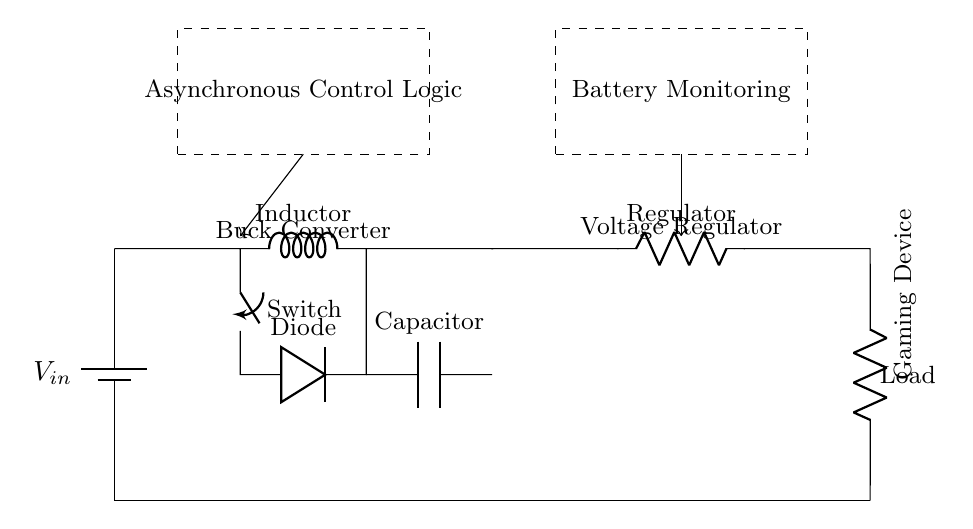What is the component used to step down voltage? The circuit includes a buck converter, which is specifically designed to reduce voltage levels efficiently. It controls the output voltage by switching and storing energy in an inductor.
Answer: Buck converter What does the dashed rectangle represent in the circuit? The dashed rectangle encloses the control logic section, which typically manages the operation of the circuit components, ensuring they function correctly according to the power management objectives.
Answer: Asynchronous Control Logic How many main sections are in this power management circuit? The circuit consists of four main sections: the battery, the buck converter, the voltage regulator, and the load (gaming device). Each plays a significant role in managing power for extended gaming.
Answer: Four Which component protects against reverse current? The diode acts as a protective element against reverse current, ensuring that the current only flows in one direction, thereby safeguarding the circuit components connected to it.
Answer: Diode What is the purpose of the inductor in this circuit? The inductor stores energy in a magnetic field when current passes through it and releases that energy, enabling efficient voltage regulation and current control as part of the buck converter circuit.
Answer: Energy storage What type of load is included in this circuit? The load connected at the end of the circuit is a gaming device, which represents the end use case of the power management design intended for extended operational periods while playing games.
Answer: Gaming Device What type of analysis is used in this circuit? The circuit employs asynchronous analysis, as indicated by the control logic that operates without synchronous dependencies, allowing for flexibility in managing power according to the gaming device's needs.
Answer: Asynchronous 